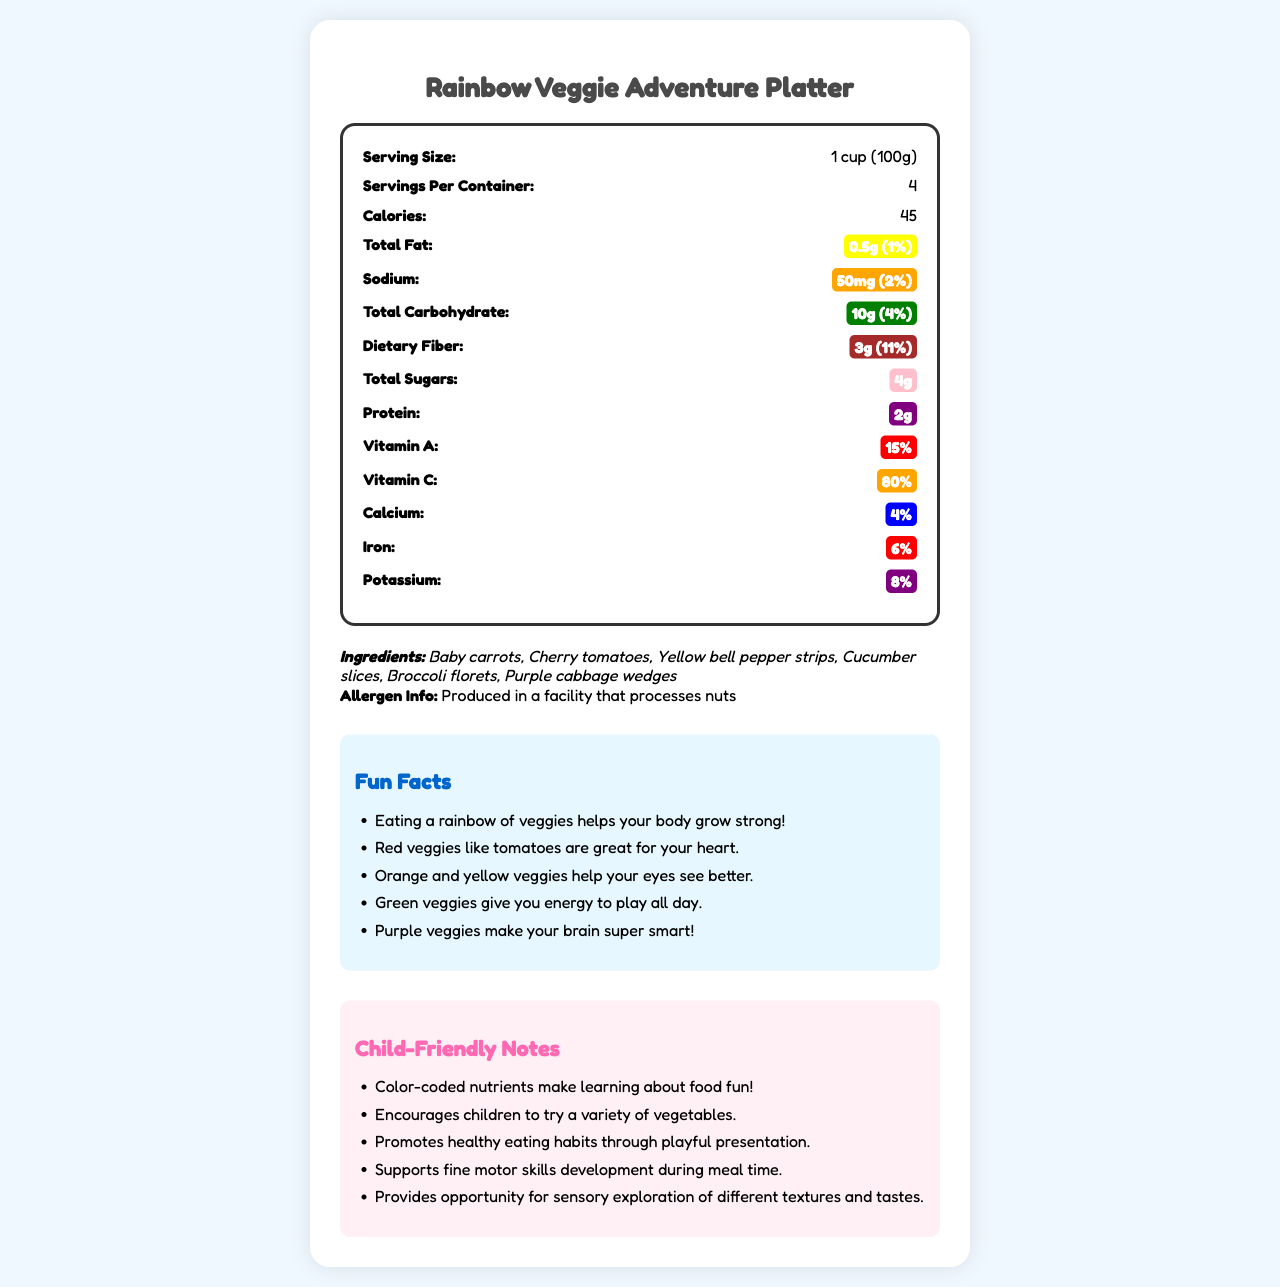what is the serving size of the Rainbow Veggie Adventure Platter? The serving size is given directly in the document under the nutrition facts section as "Serving Size: 1 cup (100g)".
Answer: 1 cup (100g) how many servings per container are there? The document states "Servings Per Container: 4" in the nutrition facts section.
Answer: 4 how many calories are in one serving? The document specifies "Calories: 45" in the nutrition facts section for one serving.
Answer: 45 how much dietary fiber is in one serving and what is its daily value percentage? The document lists "Dietary Fiber: 3g (11%)" in the nutrition facts section with a brown color-coded label.
Answer: 3g, 11% is the Rainbow Veggie Adventure Platter produced in a facility that processes nuts? The allergen information at the bottom of the document states "Produced in a facility that processes nuts".
Answer: Yes how much vitamin C does one serving provide? The document lists "Vitamin C: 80%" and this information is color-coded orange.
Answer: 80% which of the following ingredients is NOT included in the Rainbow Veggie Adventure Platter? A. Baby carrots B. Cherry tomatoes C. Spinach D. Yellow bell pepper strips The ingredients listed are Baby carrots, Cherry tomatoes, Yellow bell pepper strips, Cucumber slices, Broccoli florets, and Purple cabbage wedges. Spinach is not included.
Answer: C what is the primary benefit of eating green veggies according to the fun facts? A. Helps your heart B. Gives you energy to play all day C. Makes your eyes see better D. Makes your brain super smart According to the fun facts section, "Green veggies give you energy to play all day."
Answer: B does the Rainbow Veggie Adventure Platter provide more calcium or iron? The document shows "Calcium: 4%" and "Iron: 6%," meaning that it provides more iron.
Answer: Iron summarize the contents of the Rainbow Veggie Adventure Platter document. The document summarizes the nutritional facts such as serving size, calories, and nutrient content, lists the ingredients used, mentions allergen info, provides fun facts related to health benefits of different veggies, and includes child-friendly notes that emphasize the educational, sensory, and developmental benefits of the platter.
Answer: The Rainbow Veggie Adventure Platter document provides detailed nutritional information, including serving size, calories, and nutrient breakdown with color-coded highlights. It lists the ingredients and mentions the allergen information. Fun facts explain the benefits of different colored vegetables. Child-friendly notes promote the educational and developmental value of the platter for children. what percentage of the daily value for potassium is provided by one serving? The document lists "Potassium: 8%" with a purple color-coded label.
Answer: 8% which vitamin percentage is color-coded red and contributes to heart health? Vitamin A is color-coded red and, according to the fun facts, red veggies like tomatoes are great for your heart.
Answer: Vitamin A, 15% how much protein is in one serving? The document indicates "Protein: 2g" and this information is color-coded purple.
Answer: 2g how many grams of total sugars are in one serving? The nutrition facts list "Total Sugars: 4g" highlighted in pink.
Answer: 4g can the document provide information about other products produced in the facility? The document only mentions that the Rainbow Veggie Adventure Platter is produced in a facility that processes nuts but does not provide details about other products.
Answer: Not enough information 